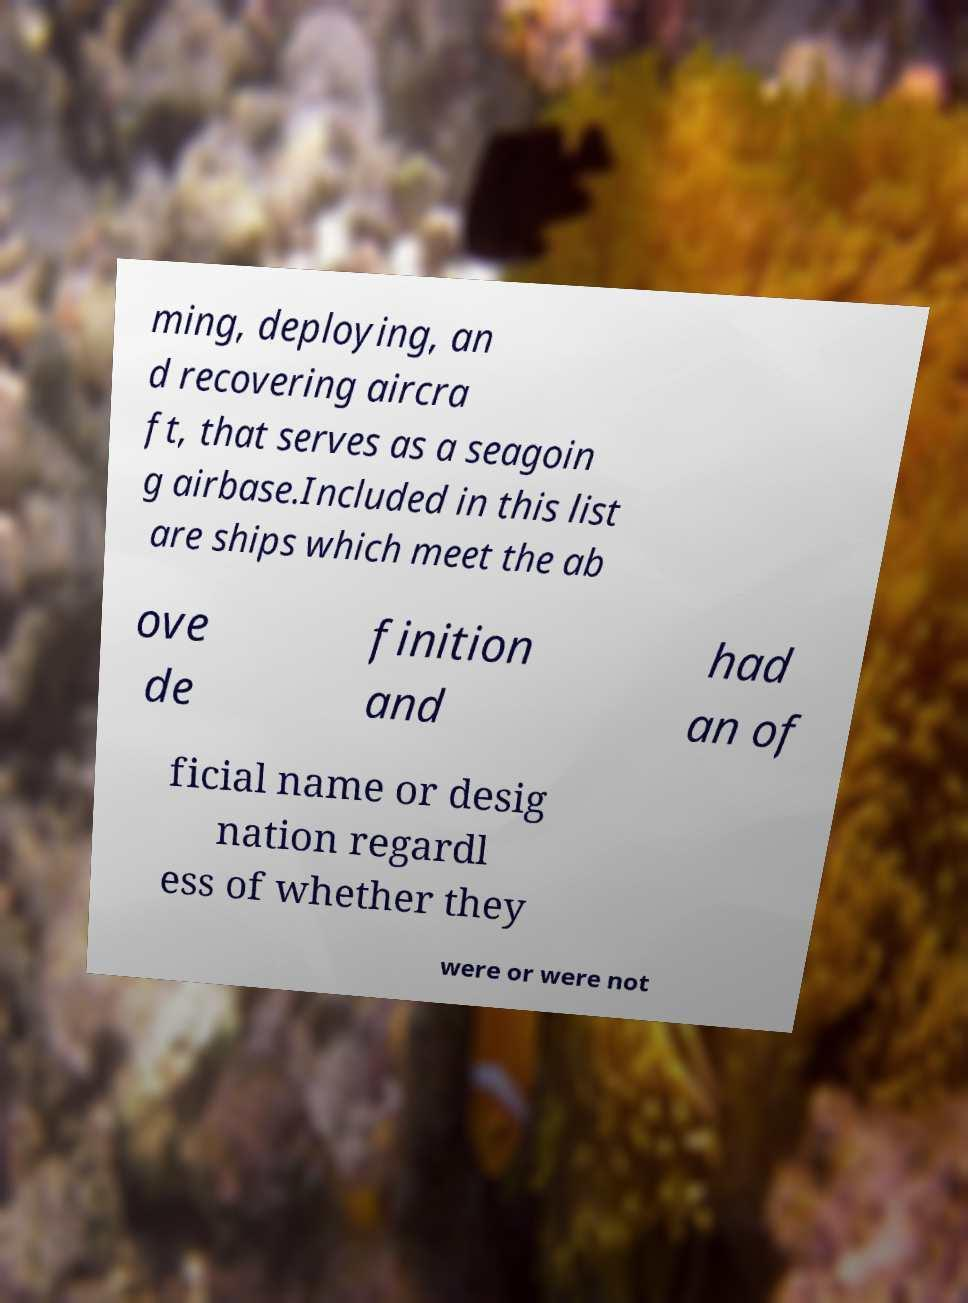There's text embedded in this image that I need extracted. Can you transcribe it verbatim? ming, deploying, an d recovering aircra ft, that serves as a seagoin g airbase.Included in this list are ships which meet the ab ove de finition and had an of ficial name or desig nation regardl ess of whether they were or were not 